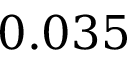Convert formula to latex. <formula><loc_0><loc_0><loc_500><loc_500>0 . 0 3 5</formula> 